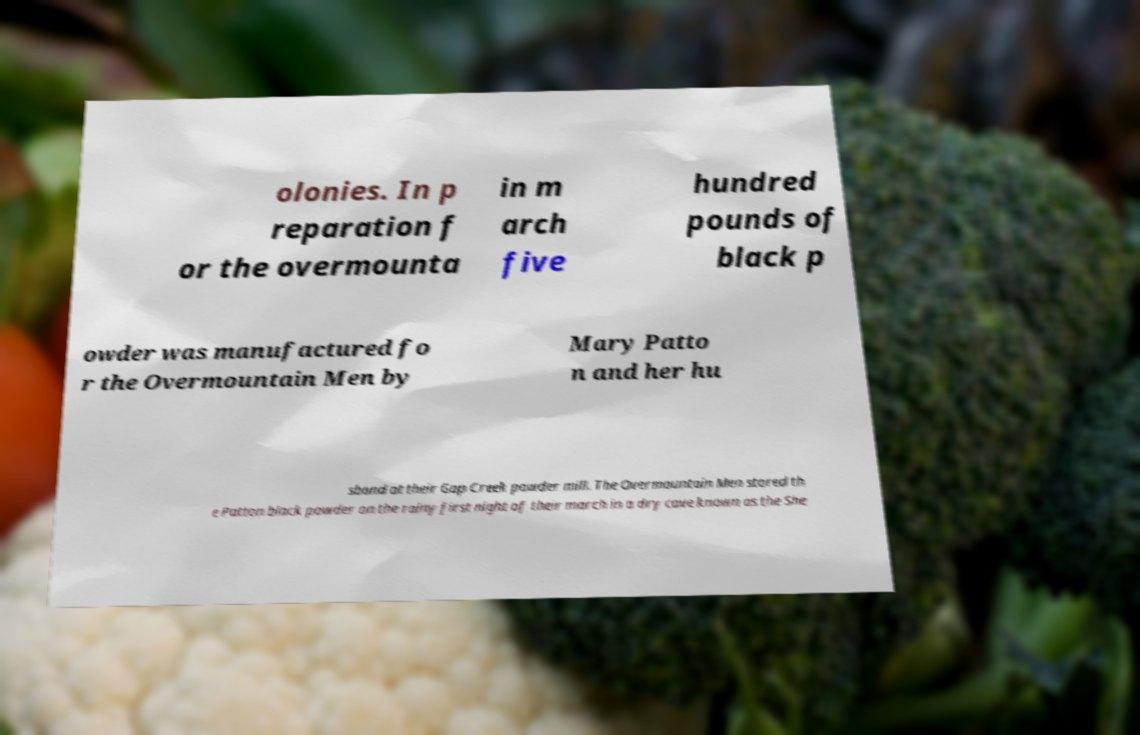There's text embedded in this image that I need extracted. Can you transcribe it verbatim? olonies. In p reparation f or the overmounta in m arch five hundred pounds of black p owder was manufactured fo r the Overmountain Men by Mary Patto n and her hu sband at their Gap Creek powder mill. The Overmountain Men stored th e Patton black powder on the rainy first night of their march in a dry cave known as the She 